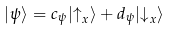Convert formula to latex. <formula><loc_0><loc_0><loc_500><loc_500>| \psi \rangle = c _ { \psi } | { \uparrow } _ { x } \rangle + d _ { \psi } | { \downarrow } _ { x } \rangle</formula> 